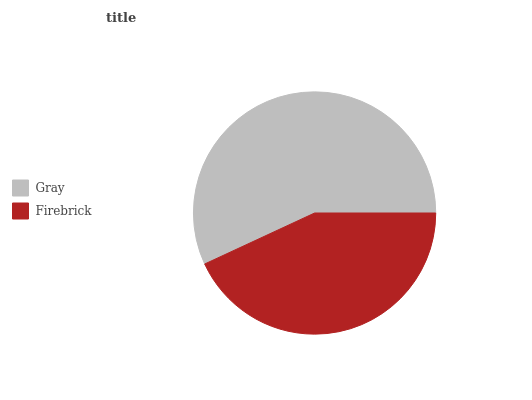Is Firebrick the minimum?
Answer yes or no. Yes. Is Gray the maximum?
Answer yes or no. Yes. Is Firebrick the maximum?
Answer yes or no. No. Is Gray greater than Firebrick?
Answer yes or no. Yes. Is Firebrick less than Gray?
Answer yes or no. Yes. Is Firebrick greater than Gray?
Answer yes or no. No. Is Gray less than Firebrick?
Answer yes or no. No. Is Gray the high median?
Answer yes or no. Yes. Is Firebrick the low median?
Answer yes or no. Yes. Is Firebrick the high median?
Answer yes or no. No. Is Gray the low median?
Answer yes or no. No. 